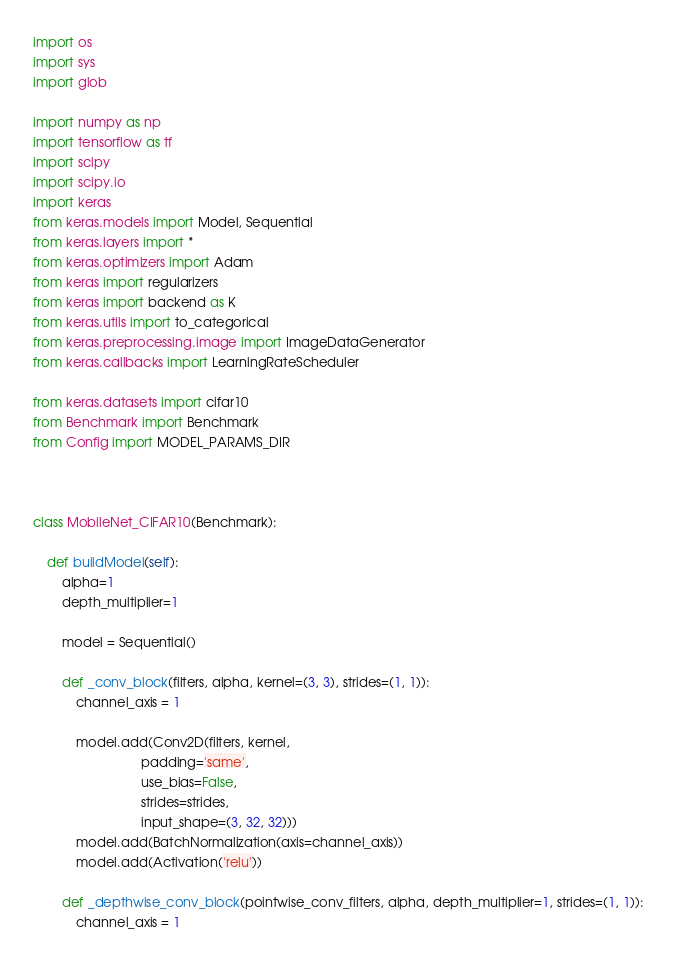Convert code to text. <code><loc_0><loc_0><loc_500><loc_500><_Python_>import os
import sys
import glob

import numpy as np
import tensorflow as tf
import scipy
import scipy.io
import keras
from keras.models import Model, Sequential
from keras.layers import *
from keras.optimizers import Adam
from keras import regularizers
from keras import backend as K
from keras.utils import to_categorical
from keras.preprocessing.image import ImageDataGenerator
from keras.callbacks import LearningRateScheduler

from keras.datasets import cifar10
from Benchmark import Benchmark
from Config import MODEL_PARAMS_DIR



class MobileNet_CIFAR10(Benchmark):

    def buildModel(self):
        alpha=1
        depth_multiplier=1

        model = Sequential()

        def _conv_block(filters, alpha, kernel=(3, 3), strides=(1, 1)):
            channel_axis = 1

            model.add(Conv2D(filters, kernel,
                              padding='same',
                              use_bias=False,
                              strides=strides, 
                              input_shape=(3, 32, 32)))
            model.add(BatchNormalization(axis=channel_axis))
            model.add(Activation('relu'))

        def _depthwise_conv_block(pointwise_conv_filters, alpha, depth_multiplier=1, strides=(1, 1)):
            channel_axis = 1 
</code> 